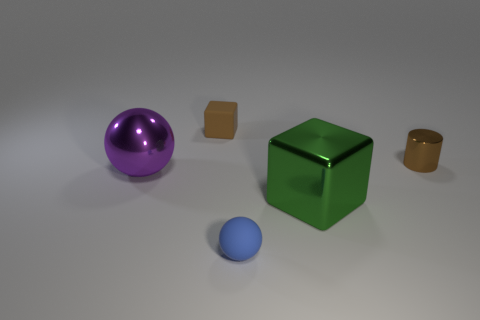What number of other things are there of the same color as the large cube?
Your answer should be compact. 0. How many metal spheres are there?
Provide a short and direct response. 1. What number of blocks are both in front of the small brown metal thing and left of the green thing?
Offer a very short reply. 0. What is the large green block made of?
Your answer should be very brief. Metal. Is there a small brown metallic cylinder?
Provide a succinct answer. Yes. There is a thing that is to the right of the green object; what is its color?
Provide a short and direct response. Brown. How many big things are in front of the tiny matte thing that is in front of the big metal object in front of the purple metal object?
Your answer should be very brief. 0. What material is the thing that is both right of the purple object and left of the small blue ball?
Keep it short and to the point. Rubber. Do the green thing and the ball that is in front of the green cube have the same material?
Keep it short and to the point. No. Is the number of large green blocks behind the small metal cylinder greater than the number of purple objects that are on the right side of the brown rubber object?
Offer a terse response. No. 